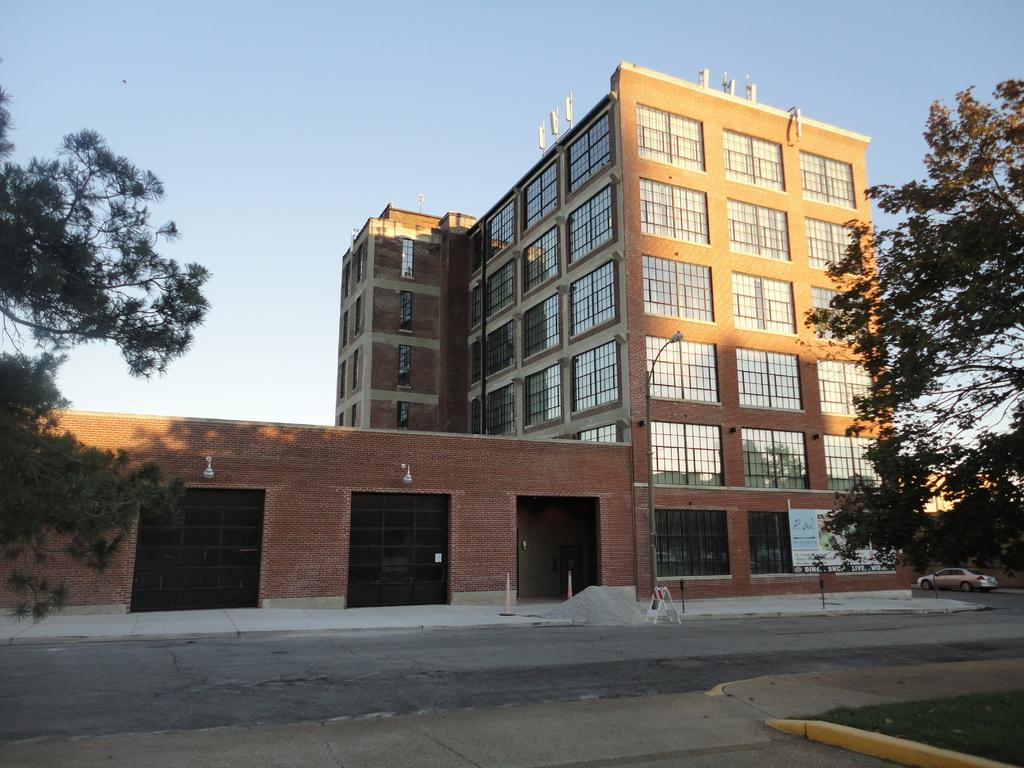What can be seen on the right side of the image? There are buildings and trees on the right side of the image. What else is present on the right side of the image? There are trees on the right side of the image. What can be seen on the left side of the image? There are trees on the left side of the image. What is the main subject of the image? The image appears to depict a view of a road. What type of sign can be seen on the road in the image? There is no sign visible on the road in the image. What type of produce is being sold by the trees on the left side of the image? There is no produce being sold by the trees in the image; they are simply trees. 